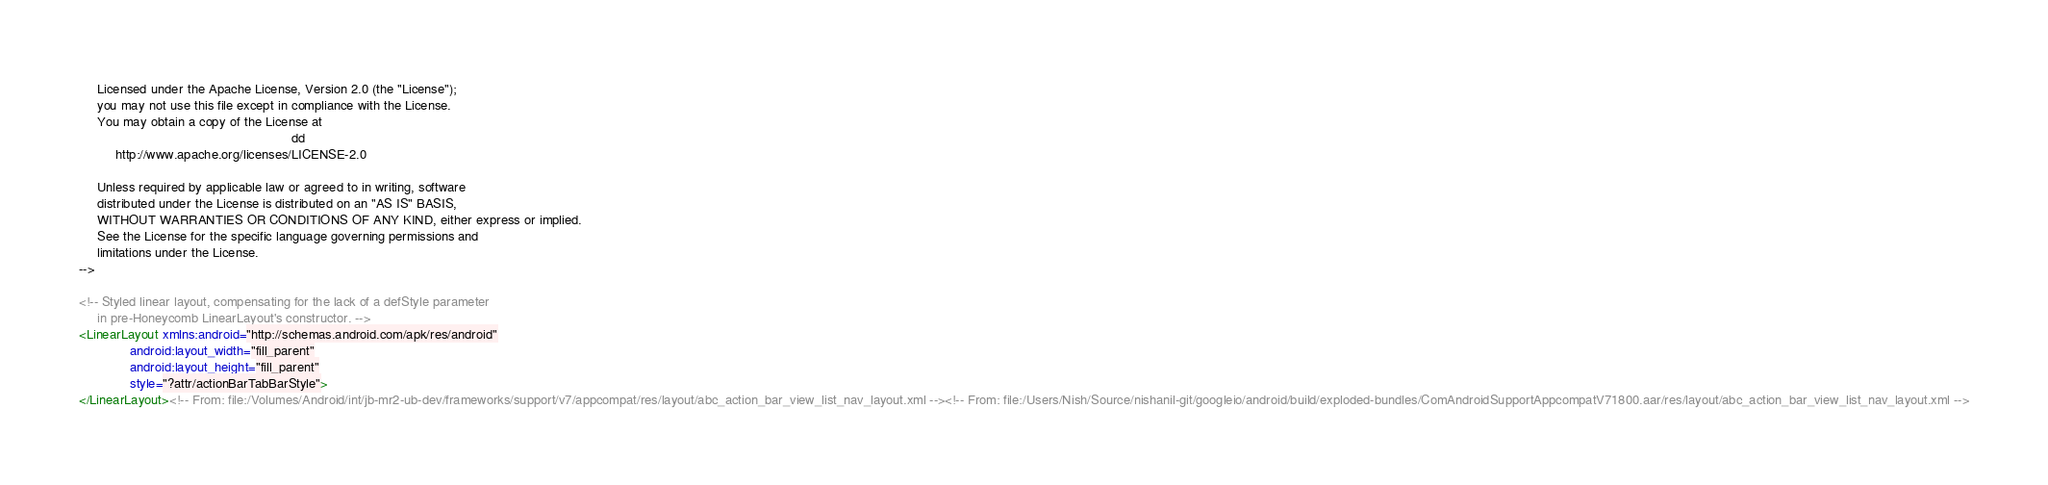<code> <loc_0><loc_0><loc_500><loc_500><_XML_>
     Licensed under the Apache License, Version 2.0 (the "License");
     you may not use this file except in compliance with the License.
     You may obtain a copy of the License at
                                                          dd
          http://www.apache.org/licenses/LICENSE-2.0

     Unless required by applicable law or agreed to in writing, software
     distributed under the License is distributed on an "AS IS" BASIS,
     WITHOUT WARRANTIES OR CONDITIONS OF ANY KIND, either express or implied.
     See the License for the specific language governing permissions and
     limitations under the License.
-->

<!-- Styled linear layout, compensating for the lack of a defStyle parameter
     in pre-Honeycomb LinearLayout's constructor. -->
<LinearLayout xmlns:android="http://schemas.android.com/apk/res/android"
              android:layout_width="fill_parent"
              android:layout_height="fill_parent"
              style="?attr/actionBarTabBarStyle">
</LinearLayout><!-- From: file:/Volumes/Android/int/jb-mr2-ub-dev/frameworks/support/v7/appcompat/res/layout/abc_action_bar_view_list_nav_layout.xml --><!-- From: file:/Users/Nish/Source/nishanil-git/googleio/android/build/exploded-bundles/ComAndroidSupportAppcompatV71800.aar/res/layout/abc_action_bar_view_list_nav_layout.xml --></code> 